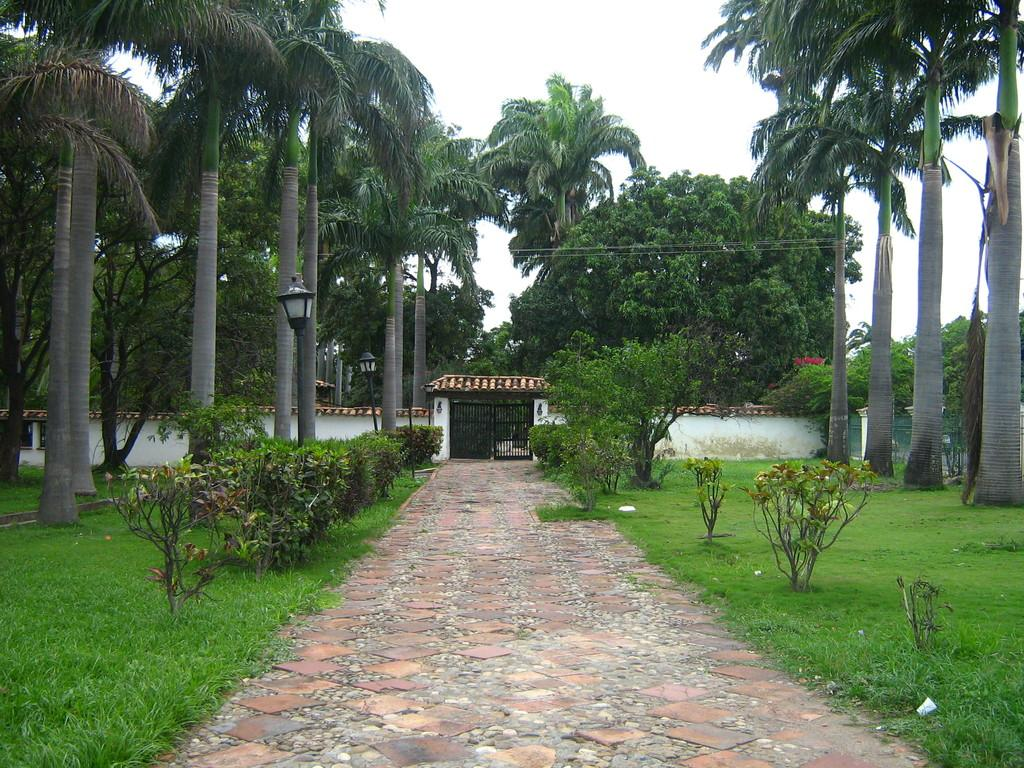What can be seen in the sky in the image? The sky is visible in the image, but no specific details about the sky are mentioned in the facts. What type of vegetation is present in the image? There are trees and plants visible in the image. What is located in the background of the image? There is a wall and a black gate in the background of the image. What is the path surrounded by in the image? Trees, green grass, and plants are present on either side of the path. How many chairs are placed around the breakfast table in the image? There is no mention of a breakfast table or chairs in the image, so this question cannot be answered definitively. 